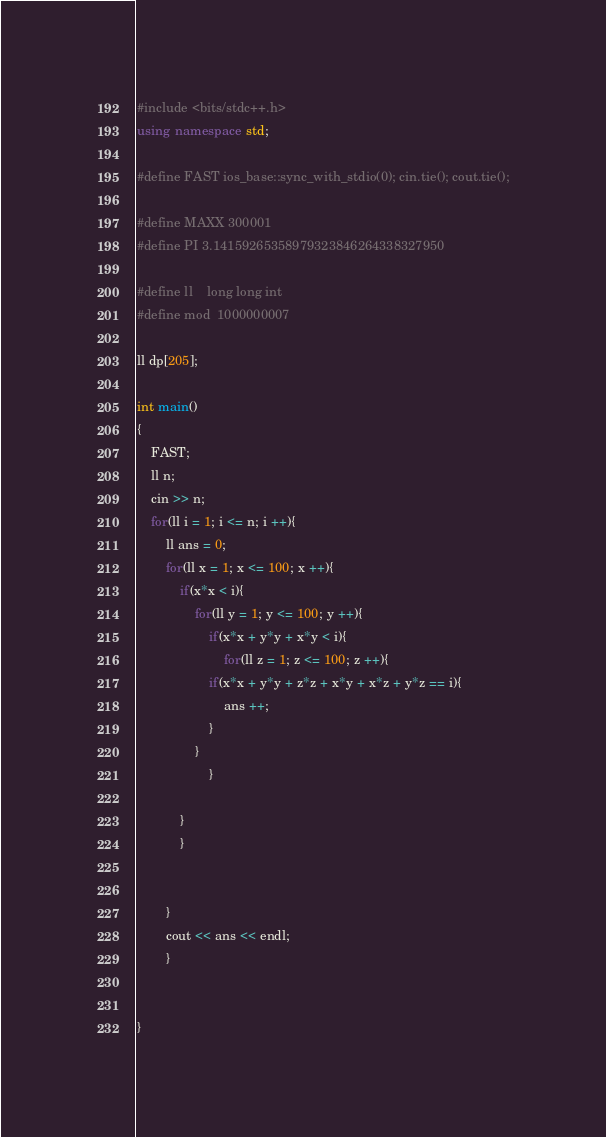<code> <loc_0><loc_0><loc_500><loc_500><_C++_>#include <bits/stdc++.h>
using namespace std;
 
#define FAST ios_base::sync_with_stdio(0); cin.tie(); cout.tie();
 
#define MAXX 300001
#define PI 3.14159265358979323846264338327950
 
#define ll    long long int 
#define mod  1000000007

ll dp[205];

int main()
{
	FAST;
	ll n;
	cin >> n;
	for(ll i = 1; i <= n; i ++){
		ll ans = 0;
		for(ll x = 1; x <= 100; x ++){
			if(x*x < i){
				for(ll y = 1; y <= 100; y ++){
					if(x*x + y*y + x*y < i){
						for(ll z = 1; z <= 100; z ++){
					if(x*x + y*y + z*z + x*y + x*z + y*z == i){
						ans ++;
					}
				}
					}
				
			}
			}
			

		}
		cout << ans << endl;		
		}
	
	
}</code> 